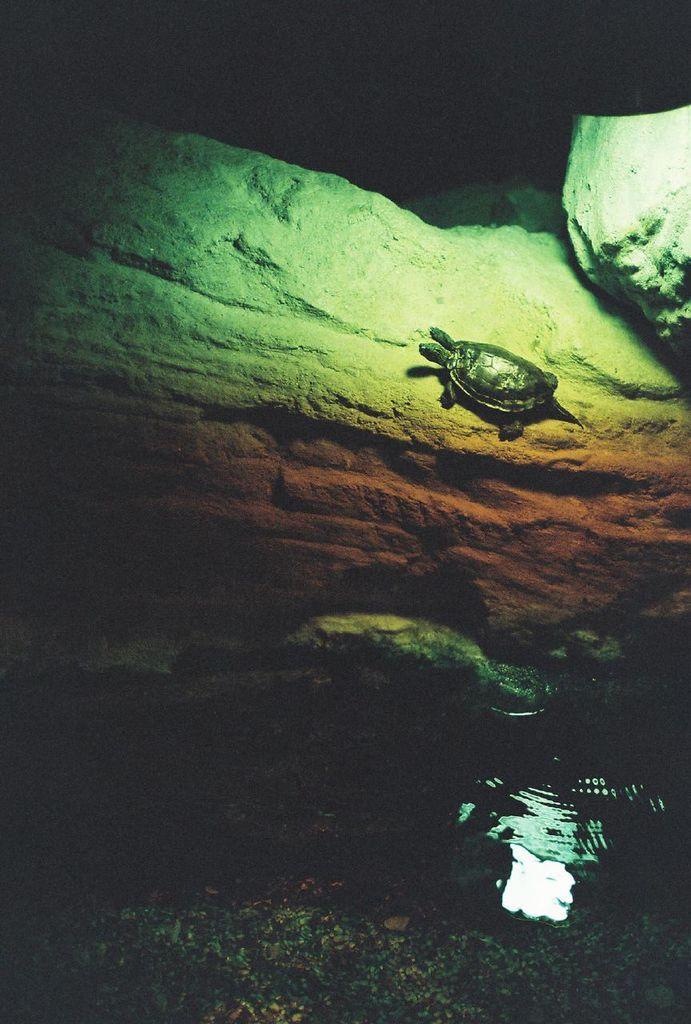Describe this image in one or two sentences. In this image we can see a turtle on the rock and we can see the water at the bottom of the image. The image is dark in the background. 